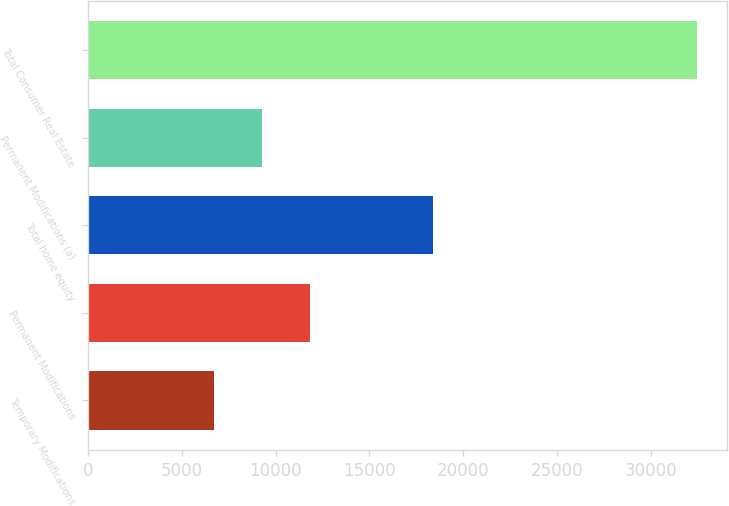Convert chart. <chart><loc_0><loc_0><loc_500><loc_500><bar_chart><fcel>Temporary Modifications<fcel>Permanent Modifications<fcel>Total home equity<fcel>Permanent Modifications (a)<fcel>Total Consumer Real Estate<nl><fcel>6683<fcel>11837.8<fcel>18400<fcel>9260.4<fcel>32457<nl></chart> 